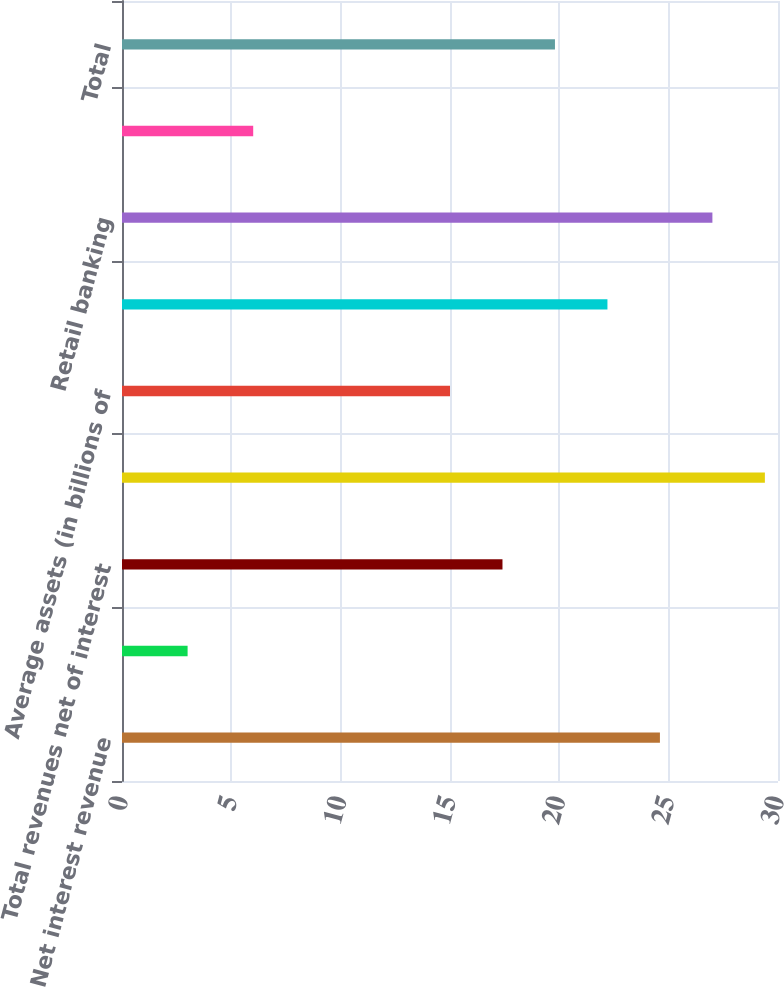Convert chart to OTSL. <chart><loc_0><loc_0><loc_500><loc_500><bar_chart><fcel>Net interest revenue<fcel>Non-interest revenue<fcel>Total revenues net of interest<fcel>Total operating expenses<fcel>Average assets (in billions of<fcel>Average deposits (in billions<fcel>Retail banking<fcel>Citi-branded cards<fcel>Total<nl><fcel>24.6<fcel>3<fcel>17.4<fcel>29.4<fcel>15<fcel>22.2<fcel>27<fcel>6<fcel>19.8<nl></chart> 